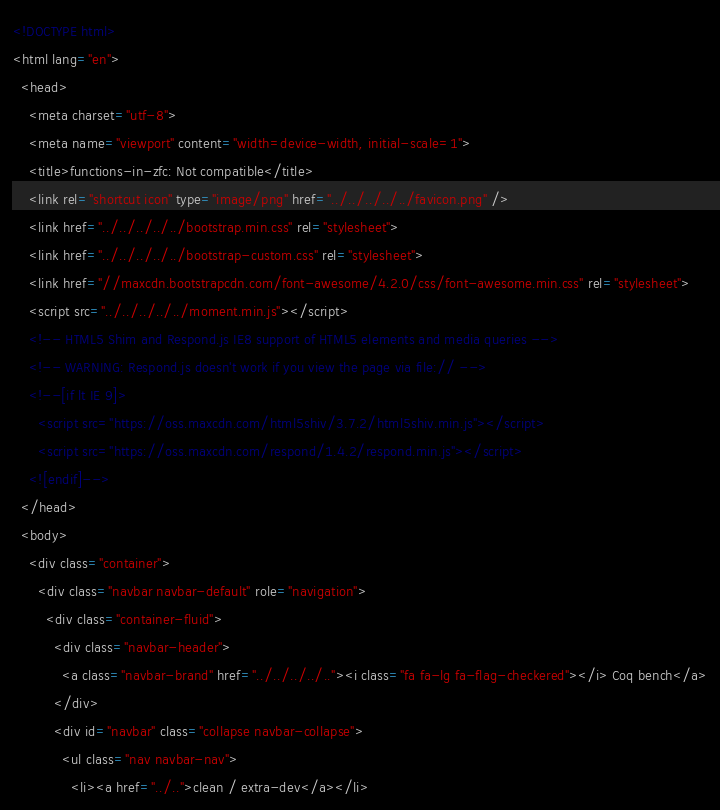<code> <loc_0><loc_0><loc_500><loc_500><_HTML_><!DOCTYPE html>
<html lang="en">
  <head>
    <meta charset="utf-8">
    <meta name="viewport" content="width=device-width, initial-scale=1">
    <title>functions-in-zfc: Not compatible</title>
    <link rel="shortcut icon" type="image/png" href="../../../../../favicon.png" />
    <link href="../../../../../bootstrap.min.css" rel="stylesheet">
    <link href="../../../../../bootstrap-custom.css" rel="stylesheet">
    <link href="//maxcdn.bootstrapcdn.com/font-awesome/4.2.0/css/font-awesome.min.css" rel="stylesheet">
    <script src="../../../../../moment.min.js"></script>
    <!-- HTML5 Shim and Respond.js IE8 support of HTML5 elements and media queries -->
    <!-- WARNING: Respond.js doesn't work if you view the page via file:// -->
    <!--[if lt IE 9]>
      <script src="https://oss.maxcdn.com/html5shiv/3.7.2/html5shiv.min.js"></script>
      <script src="https://oss.maxcdn.com/respond/1.4.2/respond.min.js"></script>
    <![endif]-->
  </head>
  <body>
    <div class="container">
      <div class="navbar navbar-default" role="navigation">
        <div class="container-fluid">
          <div class="navbar-header">
            <a class="navbar-brand" href="../../../../.."><i class="fa fa-lg fa-flag-checkered"></i> Coq bench</a>
          </div>
          <div id="navbar" class="collapse navbar-collapse">
            <ul class="nav navbar-nav">
              <li><a href="../..">clean / extra-dev</a></li></code> 